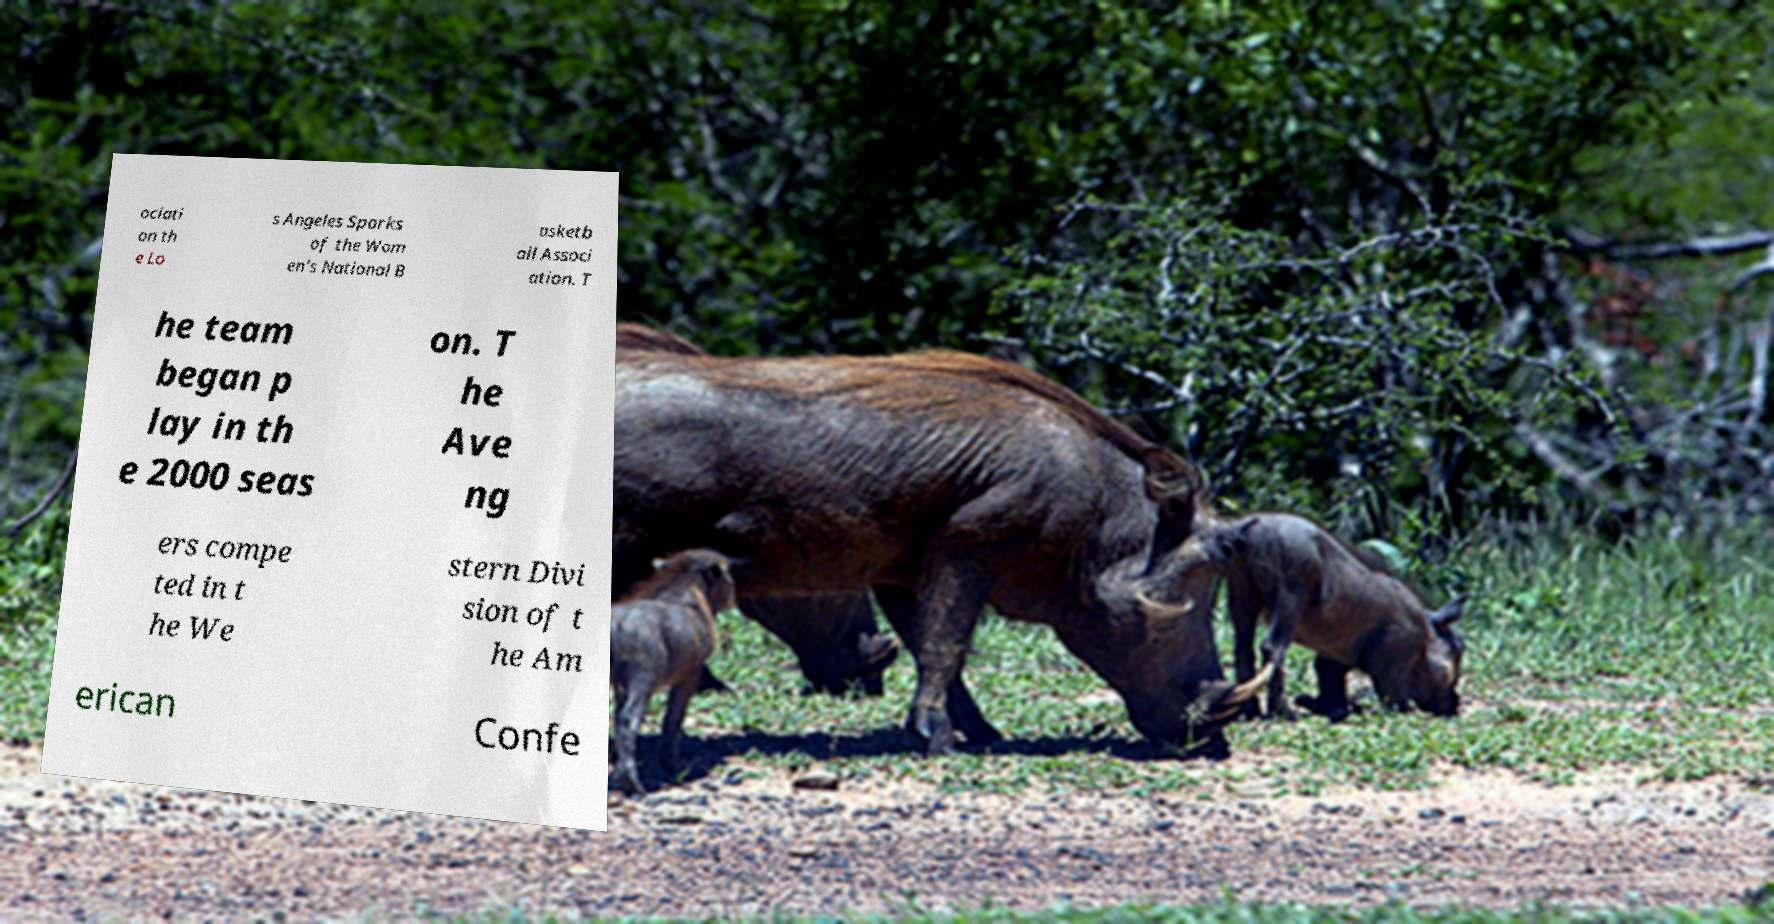Please read and relay the text visible in this image. What does it say? ociati on th e Lo s Angeles Sparks of the Wom en's National B asketb all Associ ation. T he team began p lay in th e 2000 seas on. T he Ave ng ers compe ted in t he We stern Divi sion of t he Am erican Confe 